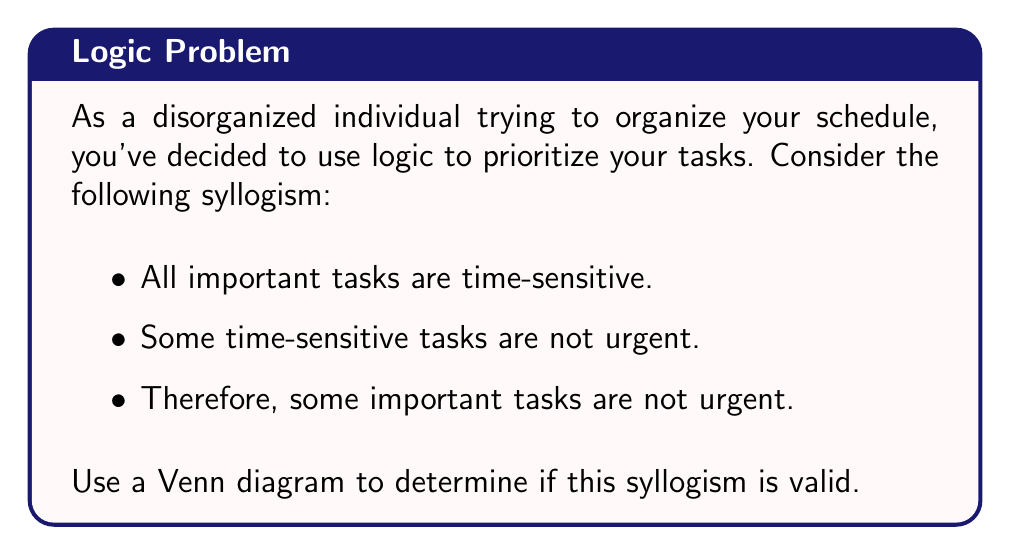Give your solution to this math problem. To determine the validity of this syllogism using a Venn diagram, we'll follow these steps:

1. Identify the three sets involved:
   A: Important tasks
   B: Time-sensitive tasks
   C: Urgent tasks

2. Draw three overlapping circles to represent these sets.

3. Represent the premises:
   Premise 1: "All important tasks are time-sensitive"
   This means that set A is entirely contained within set B.

   Premise 2: "Some time-sensitive tasks are not urgent"
   This means that there is an area in set B that is outside of set C.

4. Represent this information in the Venn diagram:

[asy]
unitsize(1cm);

pair A = (0,0), B = (1,0), C = (0.5,0.866);
real r = 1;

draw(circle(A,r), blue);
draw(circle(B,r), red);
draw(circle(C,r), green);

label("A", A, SW);
label("B", B, SE);
label("C", C, N);

fill(intersection(circle(A,r), circle(B,r) - circle(C,r)), gray(0.5));
fill(intersection(circle(B,r) - circle(A,r), circle(C,r)^complement), yellow);

label("X", (0.5,-0.5));
label("Y", (1.5,0));
[/asy]

In this diagram:
- The blue circle represents set A (Important tasks)
- The red circle represents set B (Time-sensitive tasks)
- The green circle represents set C (Urgent tasks)
- The gray area (X) represents important tasks that are time-sensitive but not urgent
- The yellow area (Y) represents time-sensitive tasks that are not important or urgent

5. Analyze the conclusion:
   The conclusion states: "Some important tasks are not urgent"
   This is represented by the gray area (X) in our Venn diagram.

6. Determine validity:
   For a syllogism to be valid, the conclusion must necessarily follow from the premises.
   In our diagram, we can see that there is indeed a region (X) where important tasks exist that are not urgent.
   This region is a logical consequence of our premises, as it must exist given the information provided.

Therefore, the syllogism is valid. The Venn diagram shows that the conclusion logically follows from the given premises.
Answer: The syllogism is valid. The Venn diagram demonstrates that there necessarily exists a set of tasks that are important and time-sensitive but not urgent, which confirms the conclusion "Some important tasks are not urgent." 